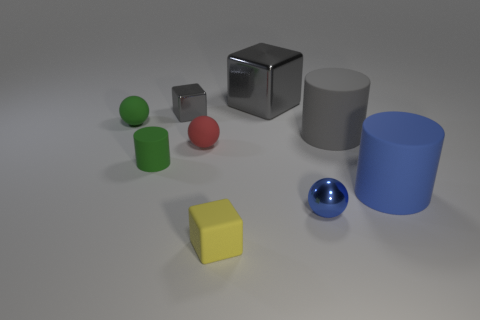There is a big blue object that is to the right of the tiny red sphere; is it the same shape as the gray metal thing to the right of the yellow cube?
Keep it short and to the point. No. There is a small metal object that is behind the big gray cylinder; is there a tiny cylinder that is behind it?
Keep it short and to the point. No. Are there any large gray things?
Your answer should be very brief. Yes. How many green spheres have the same size as the blue rubber object?
Give a very brief answer. 0. What number of things are both to the left of the small yellow cube and to the right of the large gray cube?
Keep it short and to the point. 0. There is a shiny block left of the rubber cube; does it have the same size as the blue matte cylinder?
Your response must be concise. No. Is there a small matte block that has the same color as the large metal cube?
Provide a succinct answer. No. There is a gray block that is made of the same material as the small gray object; what size is it?
Provide a succinct answer. Large. Are there more large blue cylinders that are on the right side of the blue cylinder than tiny metallic objects in front of the green cylinder?
Ensure brevity in your answer.  No. How many other objects are the same material as the green ball?
Provide a short and direct response. 5. 